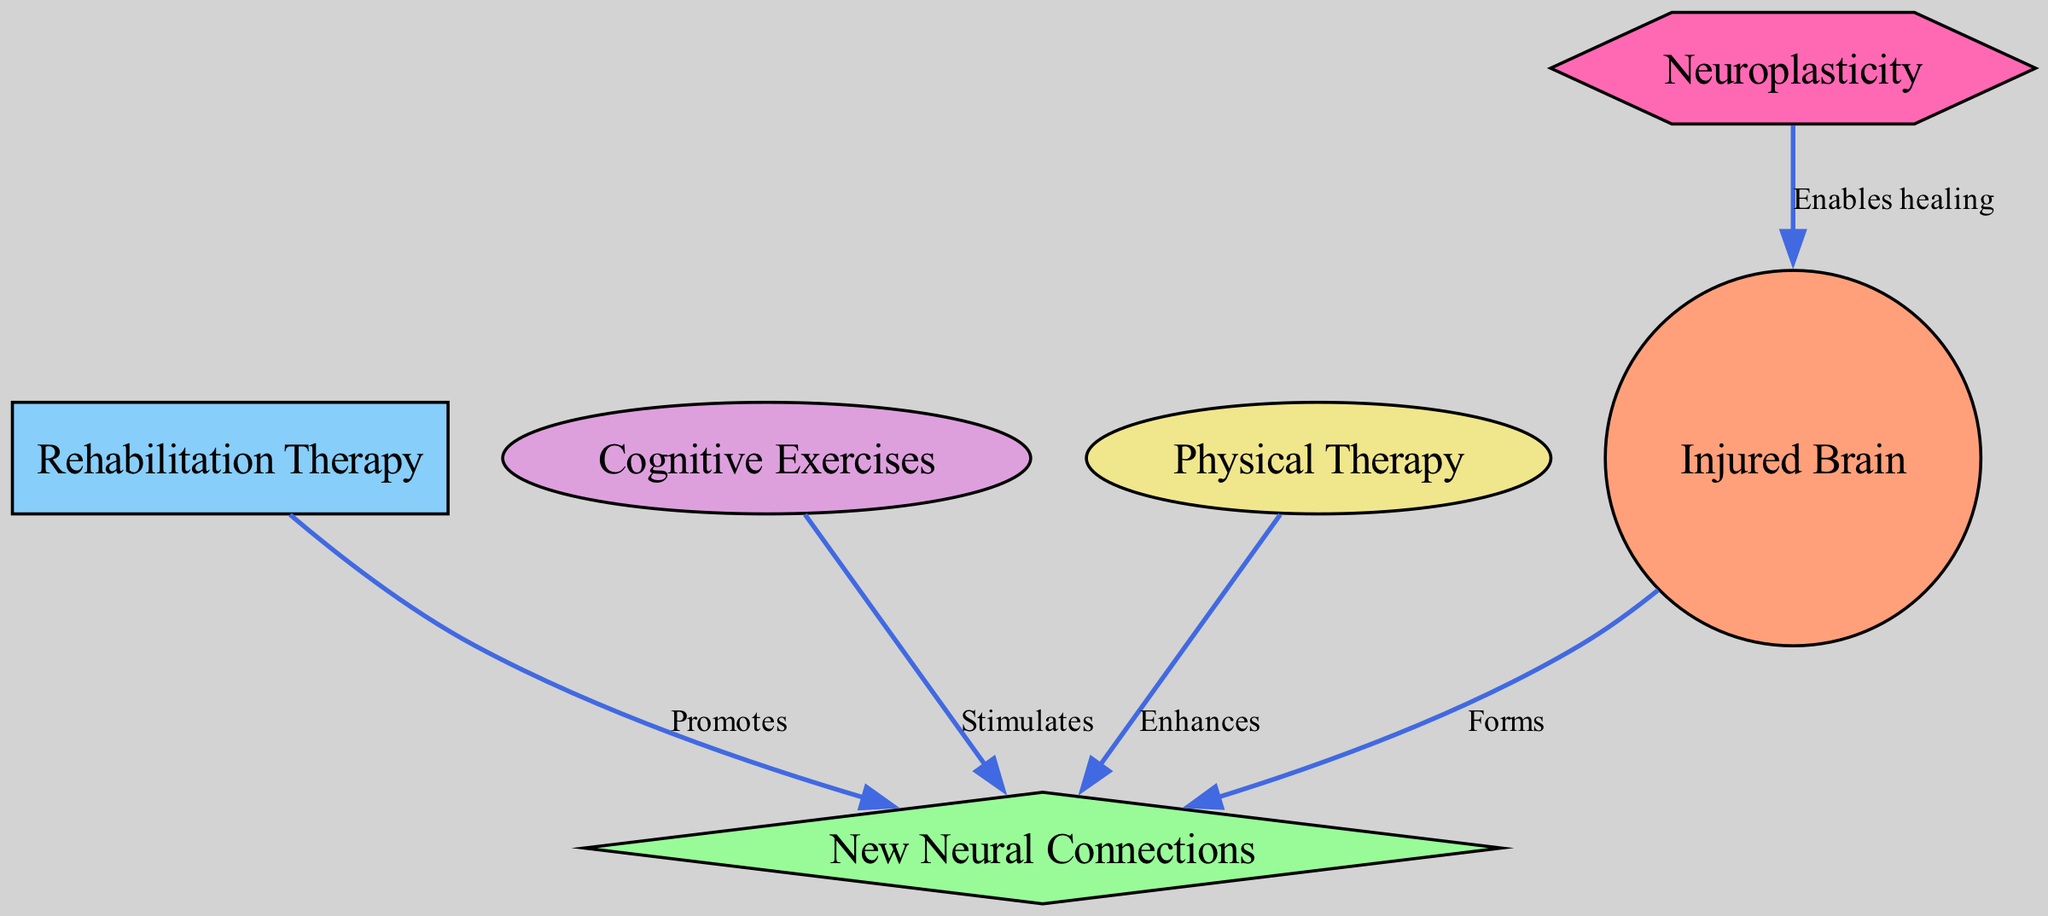What is the label of the node representing the therapeutic process? The node representing the therapeutic process is labeled "Rehabilitation Therapy." This can be identified by locating the rectangular node that corresponds to rehabilitation efforts within the diagram.
Answer: Rehabilitation Therapy How many nodes are present in the diagram? The diagram contains six nodes in total. These include "Injured Brain," "New Neural Connections," "Rehabilitation Therapy," "Cognitive Exercises," "Physical Therapy," and "Neuroplasticity." By counting each individual node listed, we arrive at the total of six.
Answer: 6 What does the 'Injured Brain' form according to the diagram? According to the diagram, the 'Injured Brain' forms 'New Neural Connections.' This relationship is represented by the directed edge that originates from the 'Injured Brain' node and points towards the 'New Neural Connections' node.
Answer: New Neural Connections Which therapy enhances new neural connections? The therapy that enhances new neural connections is identified as 'Physical Therapy.' This can be determined by examining the directed edge linked to 'Physical Therapy,' which indicates its role in promoting the formation of new neural connections.
Answer: Physical Therapy What is enabled by neuroplasticity in this diagram? Neuroplasticity enables healing of the injured brain. This is conveyed through the arrow that points from the 'Neuroplasticity' node to the 'Injured Brain' node, indicating the healing function facilitated by neuroplasticity.
Answer: Healing Which types of exercises stimulate new neural connections? 'Cognitive Exercises' are specified as the type of exercises that stimulate new neural connections. This is shown in the diagram by the directed edge from the 'Cognitive Exercises' node to the 'New Neural Connections' node.
Answer: Cognitive Exercises 